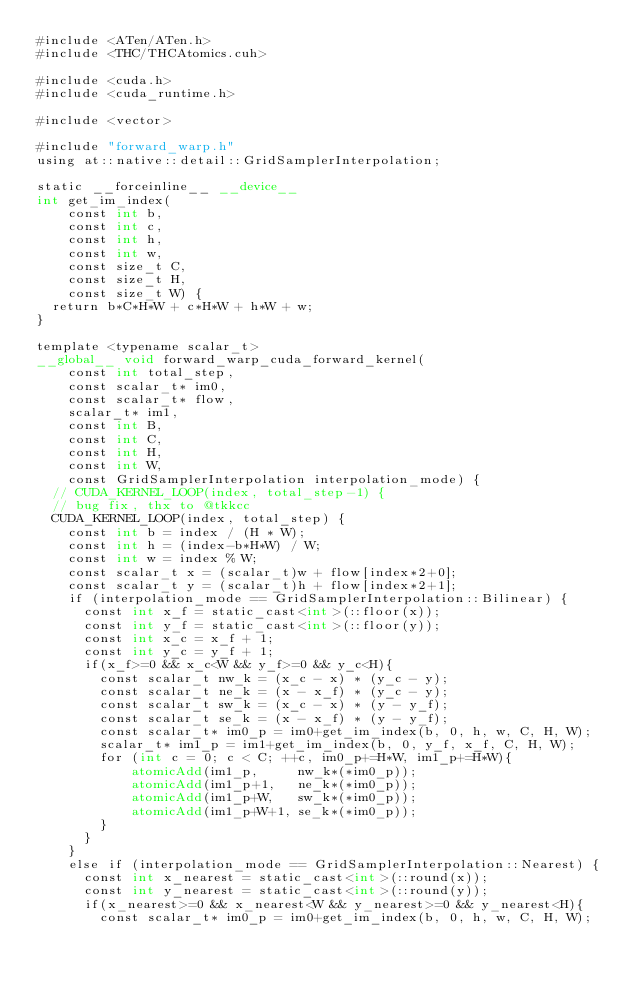Convert code to text. <code><loc_0><loc_0><loc_500><loc_500><_Cuda_>#include <ATen/ATen.h>
#include <THC/THCAtomics.cuh>

#include <cuda.h>
#include <cuda_runtime.h>

#include <vector>

#include "forward_warp.h"
using at::native::detail::GridSamplerInterpolation;

static __forceinline__ __device__ 
int get_im_index(
    const int b,
    const int c,
    const int h,
    const int w,
    const size_t C,
    const size_t H,
    const size_t W) {
  return b*C*H*W + c*H*W + h*W + w;
}

template <typename scalar_t>
__global__ void forward_warp_cuda_forward_kernel(
    const int total_step,
    const scalar_t* im0,
    const scalar_t* flow,
    scalar_t* im1,
    const int B,
    const int C,
    const int H,
    const int W,
    const GridSamplerInterpolation interpolation_mode) {
  // CUDA_KERNEL_LOOP(index, total_step-1) {
  // bug fix, thx to @tkkcc
  CUDA_KERNEL_LOOP(index, total_step) {
    const int b = index / (H * W);
    const int h = (index-b*H*W) / W;
    const int w = index % W;
    const scalar_t x = (scalar_t)w + flow[index*2+0];
    const scalar_t y = (scalar_t)h + flow[index*2+1];
    if (interpolation_mode == GridSamplerInterpolation::Bilinear) {
      const int x_f = static_cast<int>(::floor(x));
      const int y_f = static_cast<int>(::floor(y));
      const int x_c = x_f + 1;
      const int y_c = y_f + 1;
      if(x_f>=0 && x_c<W && y_f>=0 && y_c<H){
        const scalar_t nw_k = (x_c - x) * (y_c - y);
        const scalar_t ne_k = (x - x_f) * (y_c - y);
        const scalar_t sw_k = (x_c - x) * (y - y_f);
        const scalar_t se_k = (x - x_f) * (y - y_f);
        const scalar_t* im0_p = im0+get_im_index(b, 0, h, w, C, H, W);
        scalar_t* im1_p = im1+get_im_index(b, 0, y_f, x_f, C, H, W);
        for (int c = 0; c < C; ++c, im0_p+=H*W, im1_p+=H*W){
            atomicAdd(im1_p,     nw_k*(*im0_p));
            atomicAdd(im1_p+1,   ne_k*(*im0_p));
            atomicAdd(im1_p+W,   sw_k*(*im0_p));
            atomicAdd(im1_p+W+1, se_k*(*im0_p));
        }
      }
    } 
    else if (interpolation_mode == GridSamplerInterpolation::Nearest) {
      const int x_nearest = static_cast<int>(::round(x));
      const int y_nearest = static_cast<int>(::round(y));
      if(x_nearest>=0 && x_nearest<W && y_nearest>=0 && y_nearest<H){
        const scalar_t* im0_p = im0+get_im_index(b, 0, h, w, C, H, W);</code> 